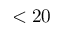<formula> <loc_0><loc_0><loc_500><loc_500>< 2 0</formula> 